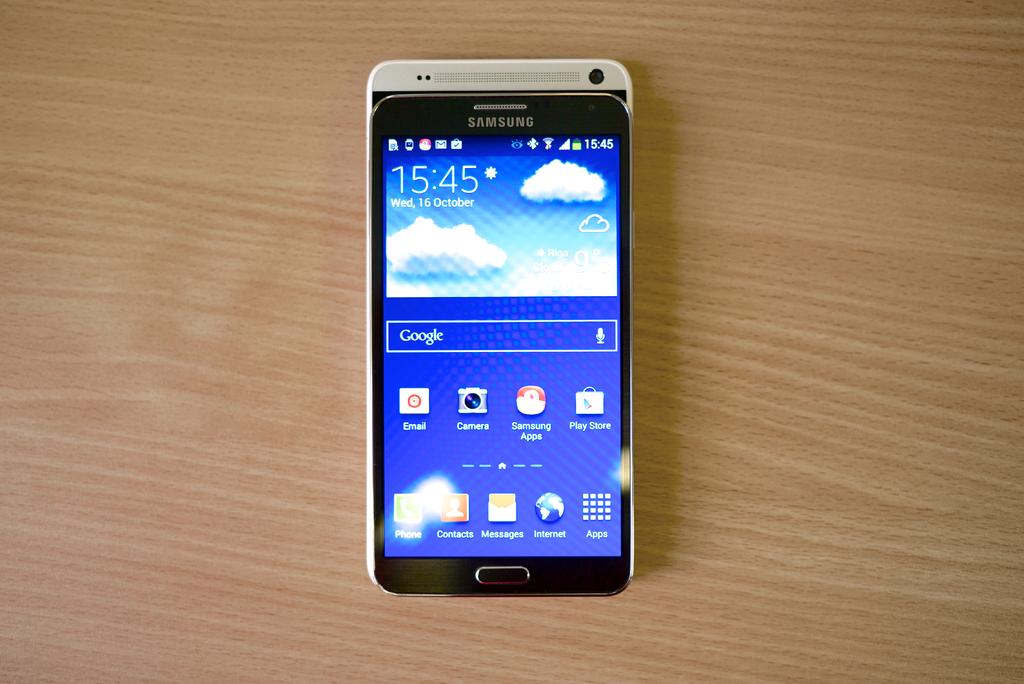What is the date on this phone?
Provide a succinct answer. 16 october. What time is displayed?
Provide a short and direct response. 15:45. 